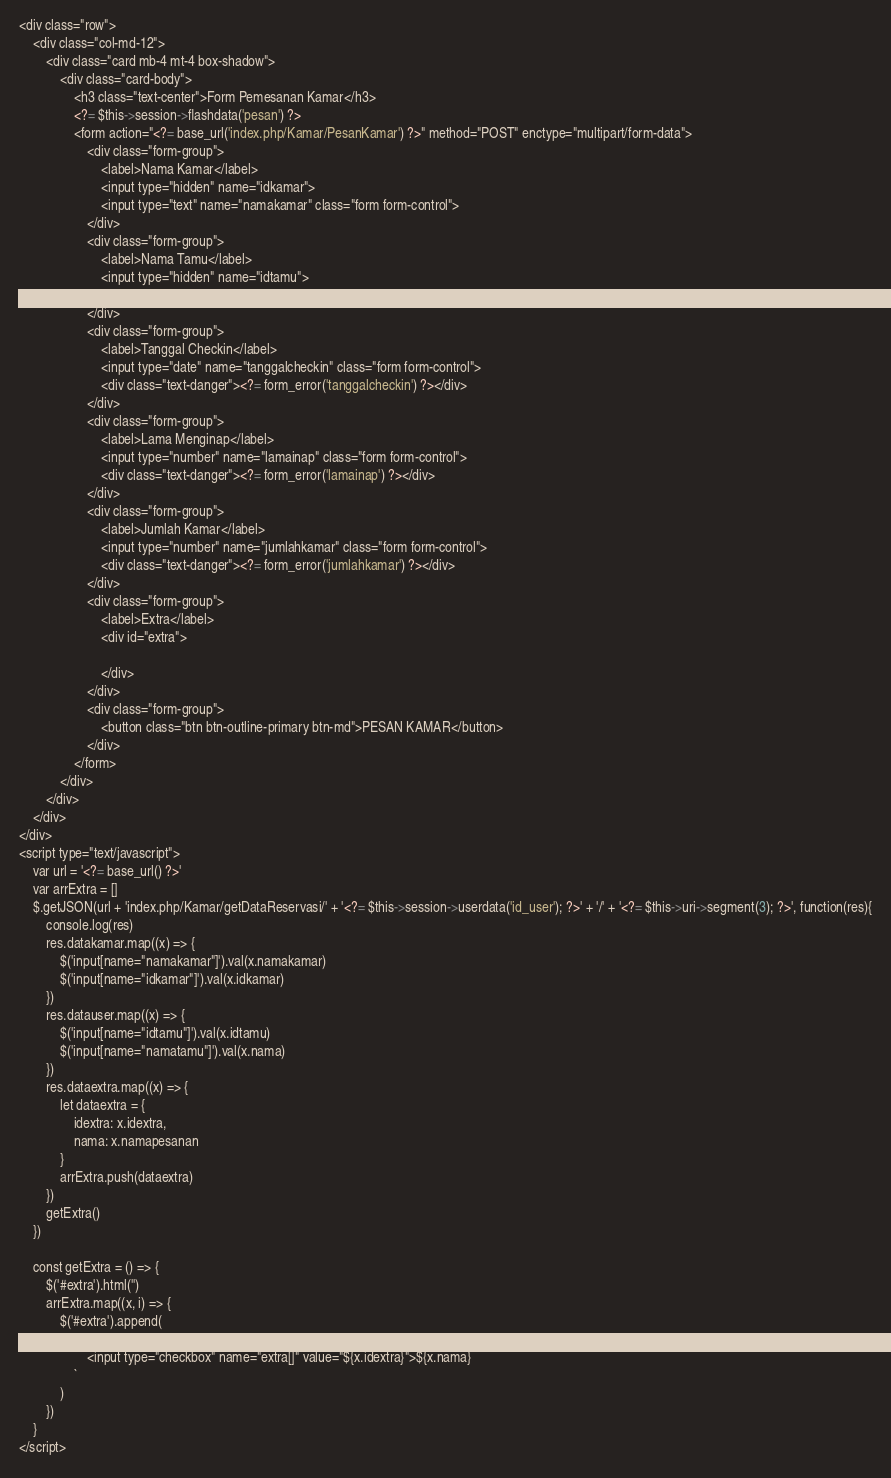Convert code to text. <code><loc_0><loc_0><loc_500><loc_500><_PHP_><div class="row">
    <div class="col-md-12">
        <div class="card mb-4 mt-4 box-shadow">
            <div class="card-body">
                <h3 class="text-center">Form Pemesanan Kamar</h3>
                <?= $this->session->flashdata('pesan') ?>
                <form action="<?= base_url('index.php/Kamar/PesanKamar') ?>" method="POST" enctype="multipart/form-data">
                    <div class="form-group">
                        <label>Nama Kamar</label>
                        <input type="hidden" name="idkamar">
                        <input type="text" name="namakamar" class="form form-control">
                    </div>
                    <div class="form-group">
                        <label>Nama Tamu</label>
                        <input type="hidden" name="idtamu">
                        <input type="text" name="namatamu" class="form form-control">
                    </div> 
                    <div class="form-group">
                        <label>Tanggal Checkin</label>
                        <input type="date" name="tanggalcheckin" class="form form-control">
                        <div class="text-danger"><?= form_error('tanggalcheckin') ?></div>
                    </div> 
                    <div class="form-group">
                        <label>Lama Menginap</label>
                        <input type="number" name="lamainap" class="form form-control">
                        <div class="text-danger"><?= form_error('lamainap') ?></div>
                    </div>
                    <div class="form-group">
                        <label>Jumlah Kamar</label>
                        <input type="number" name="jumlahkamar" class="form form-control">
                        <div class="text-danger"><?= form_error('jumlahkamar') ?></div>
                    </div>
                    <div class="form-group">
                        <label>Extra</label>
                        <div id="extra">
                            
                        </div>
                    </div>
                    <div class="form-group">
                        <button class="btn btn-outline-primary btn-md">PESAN KAMAR</button>
                    </div>
                </form>
            </div>
        </div>
    </div>
</div>
<script type="text/javascript">
    var url = '<?= base_url() ?>'
    var arrExtra = []
    $.getJSON(url + 'index.php/Kamar/getDataReservasi/' + '<?= $this->session->userdata('id_user'); ?>' + '/' + '<?= $this->uri->segment(3); ?>', function(res){
        console.log(res)
        res.datakamar.map((x) => {
            $('input[name="namakamar"]').val(x.namakamar)
            $('input[name="idkamar"]').val(x.idkamar)
        })
        res.datauser.map((x) => {
            $('input[name="idtamu"]').val(x.idtamu)
            $('input[name="namatamu"]').val(x.nama)
        })
        res.dataextra.map((x) => {
            let dataextra = {
                idextra: x.idextra,
                nama: x.namapesanan
            }
            arrExtra.push(dataextra)
        })
        getExtra()
    })

    const getExtra = () => {
        $('#extra').html('')
        arrExtra.map((x, i) => {
            $('#extra').append(
                `
                    <input type="checkbox" name="extra[]" value="${x.idextra}">${x.nama}
                `
            )
        })
    }
</script></code> 